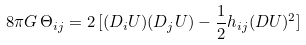<formula> <loc_0><loc_0><loc_500><loc_500>8 \pi G \, \Theta _ { i j } = 2 \, [ ( D _ { i } U ) ( D _ { j } U ) - \frac { 1 } { 2 } h _ { i j } ( D U ) ^ { 2 } ]</formula> 